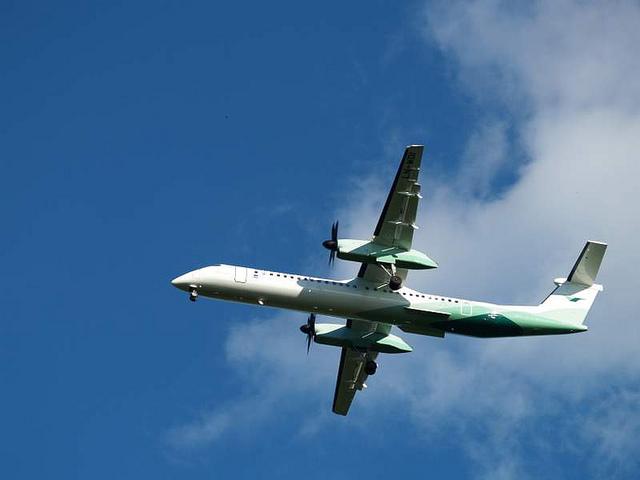Is the sky clear?
Short answer required. No. Is this a newer jet?
Short answer required. Yes. How does the plane stay in the sky?
Give a very brief answer. Propellers. Is it raining?
Give a very brief answer. No. How many engines does the airplane have?
Write a very short answer. 2. How many clouds are visible in this photo?
Be succinct. 1. Are the wheels up?
Write a very short answer. Yes. What color is the logo?
Write a very short answer. Green. Is this a military aircraft?
Answer briefly. No. Is the plane flying above the clouds?
Be succinct. No. Is this a commercial plane?
Concise answer only. Yes. 